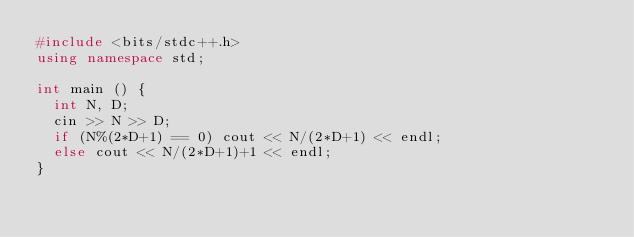Convert code to text. <code><loc_0><loc_0><loc_500><loc_500><_C++_>#include <bits/stdc++.h>
using namespace std;

int main () {
  int N, D;
  cin >> N >> D;
  if (N%(2*D+1) == 0) cout << N/(2*D+1) << endl;
  else cout << N/(2*D+1)+1 << endl;
}</code> 